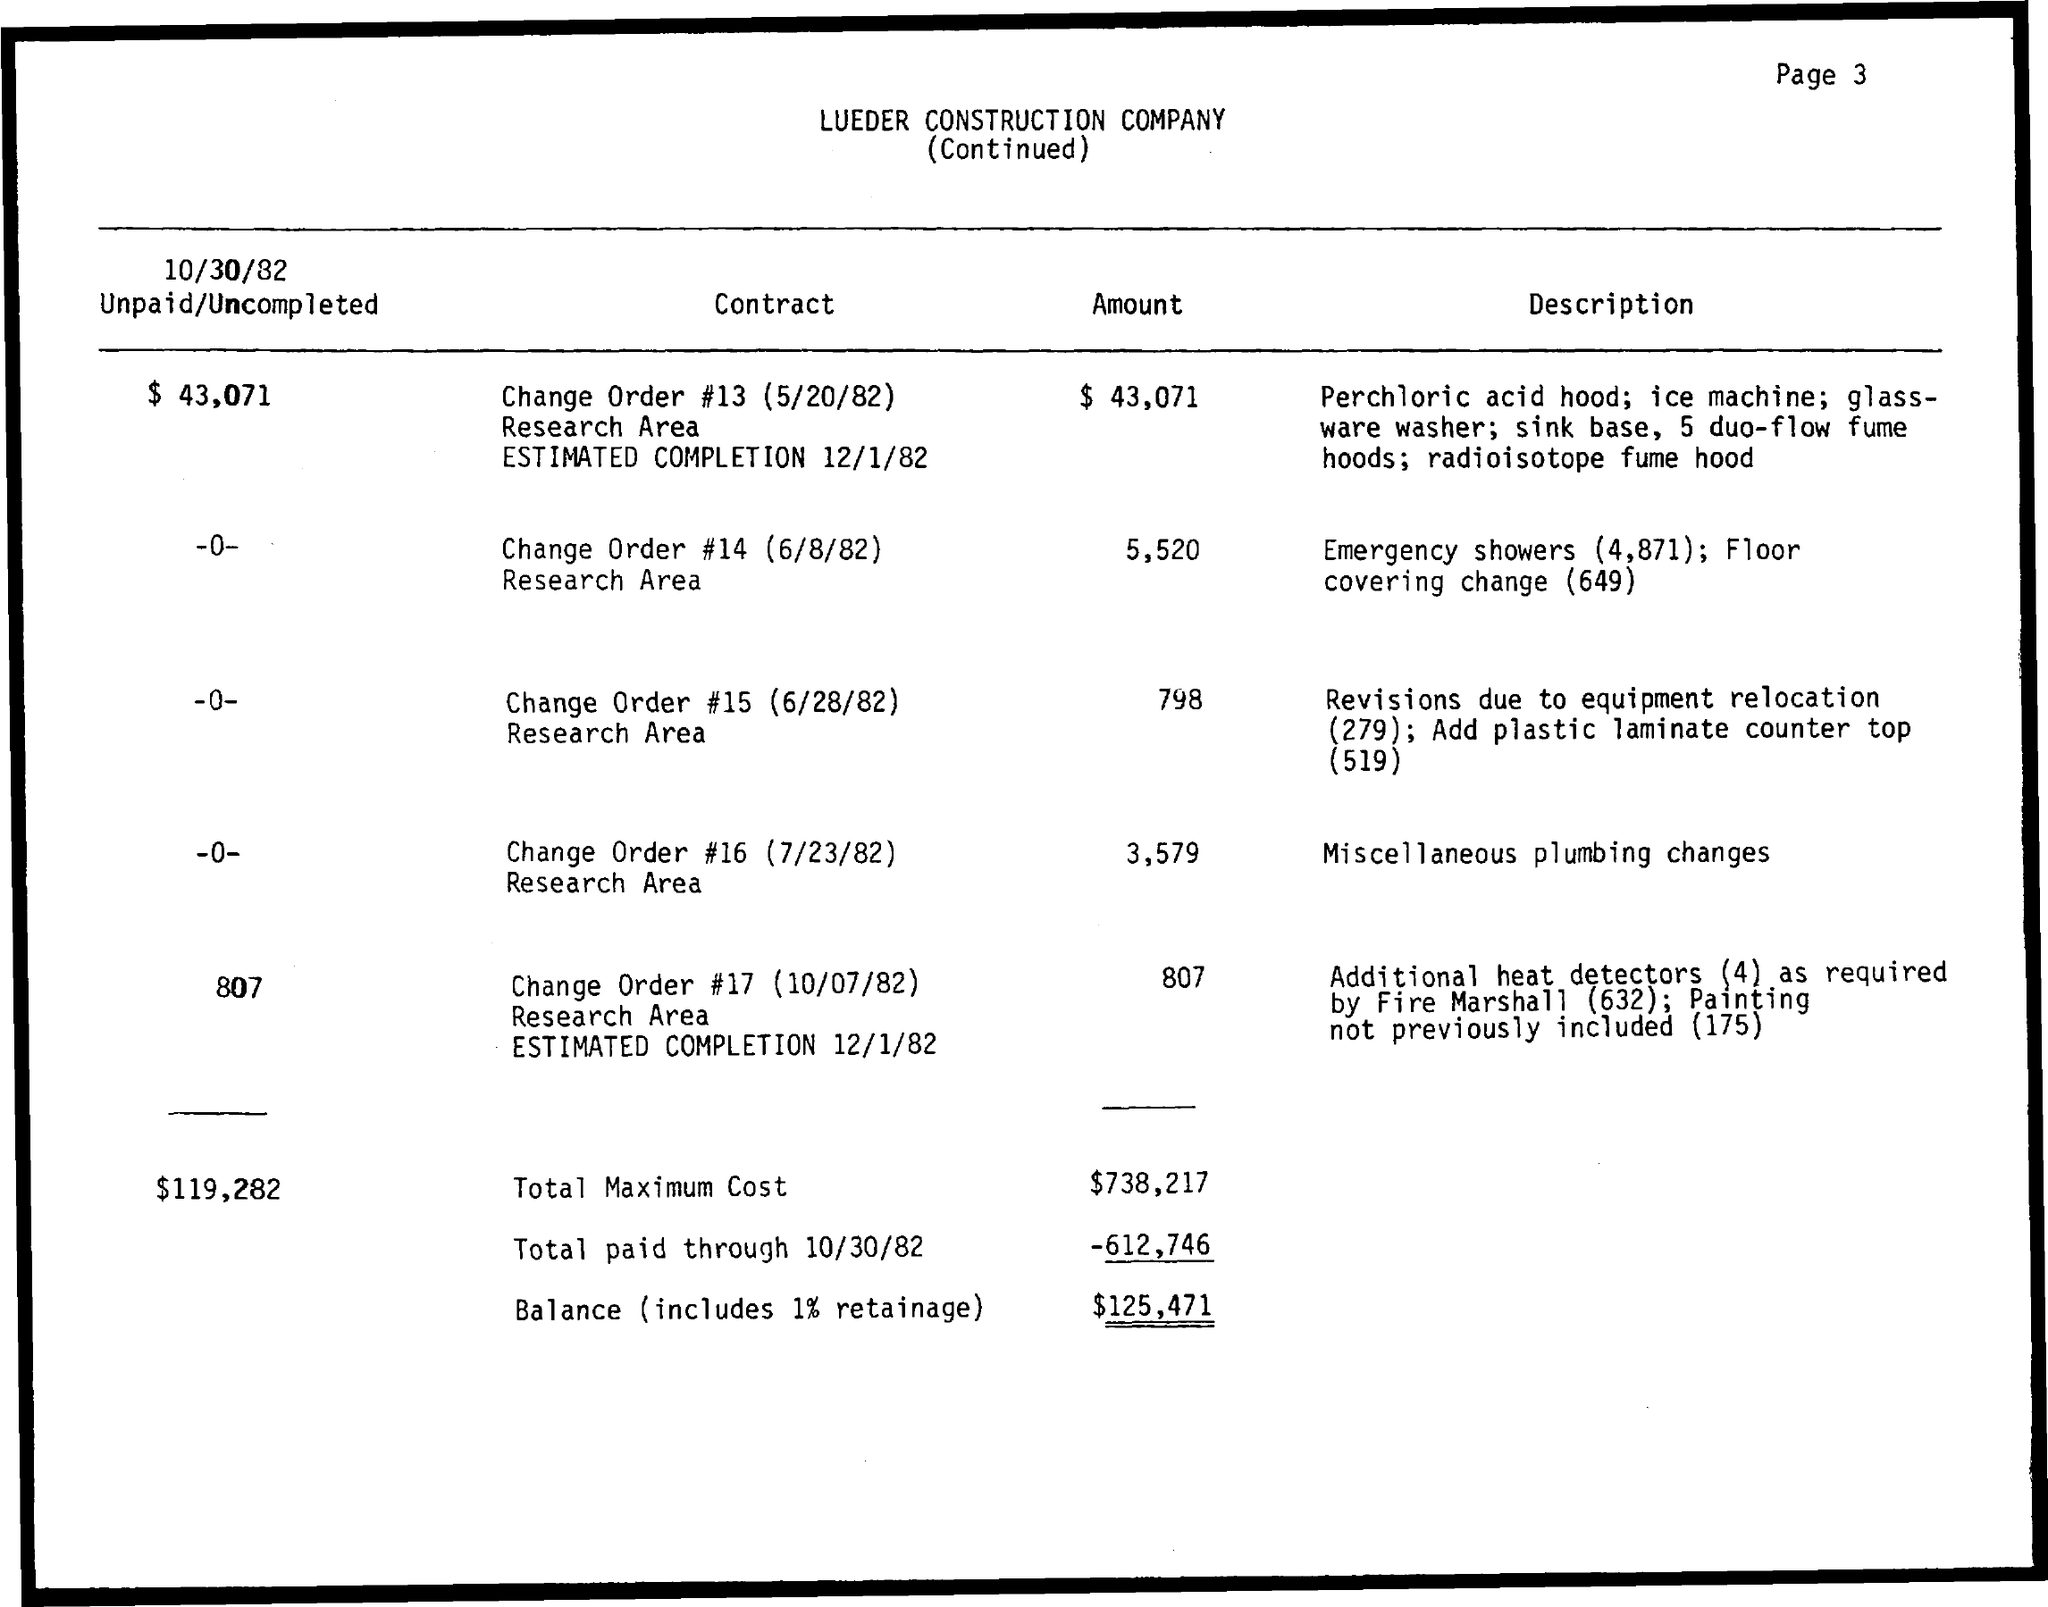What is the total maximum cost?
Make the answer very short. $738,217. 